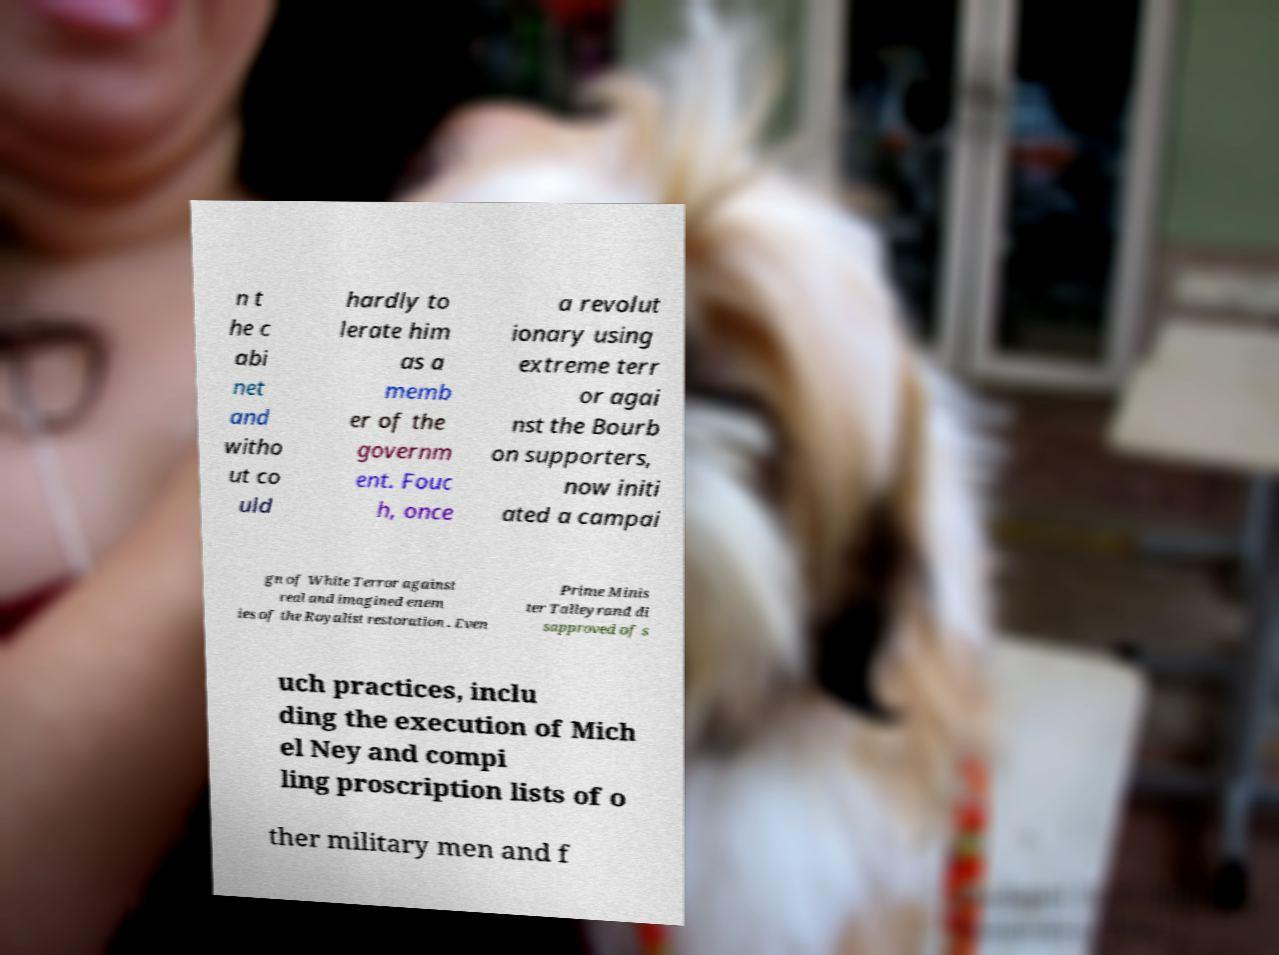Please identify and transcribe the text found in this image. n t he c abi net and witho ut co uld hardly to lerate him as a memb er of the governm ent. Fouc h, once a revolut ionary using extreme terr or agai nst the Bourb on supporters, now initi ated a campai gn of White Terror against real and imagined enem ies of the Royalist restoration . Even Prime Minis ter Talleyrand di sapproved of s uch practices, inclu ding the execution of Mich el Ney and compi ling proscription lists of o ther military men and f 